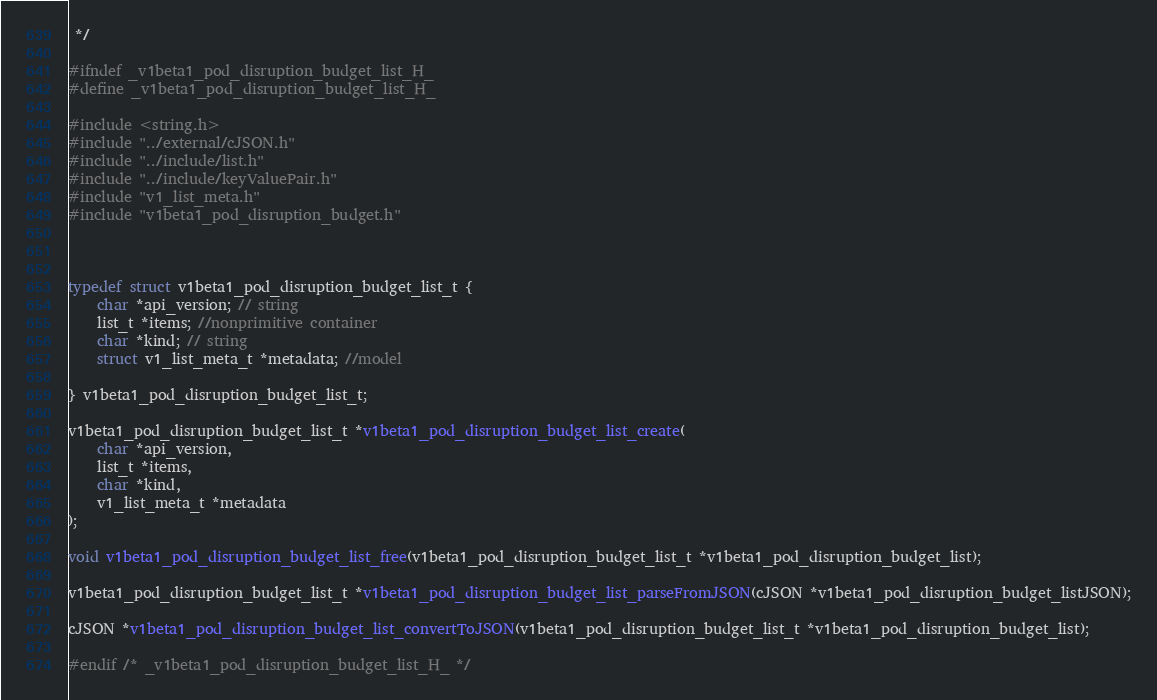<code> <loc_0><loc_0><loc_500><loc_500><_C_> */

#ifndef _v1beta1_pod_disruption_budget_list_H_
#define _v1beta1_pod_disruption_budget_list_H_

#include <string.h>
#include "../external/cJSON.h"
#include "../include/list.h"
#include "../include/keyValuePair.h"
#include "v1_list_meta.h"
#include "v1beta1_pod_disruption_budget.h"



typedef struct v1beta1_pod_disruption_budget_list_t {
    char *api_version; // string
    list_t *items; //nonprimitive container
    char *kind; // string
    struct v1_list_meta_t *metadata; //model

} v1beta1_pod_disruption_budget_list_t;

v1beta1_pod_disruption_budget_list_t *v1beta1_pod_disruption_budget_list_create(
    char *api_version,
    list_t *items,
    char *kind,
    v1_list_meta_t *metadata
);

void v1beta1_pod_disruption_budget_list_free(v1beta1_pod_disruption_budget_list_t *v1beta1_pod_disruption_budget_list);

v1beta1_pod_disruption_budget_list_t *v1beta1_pod_disruption_budget_list_parseFromJSON(cJSON *v1beta1_pod_disruption_budget_listJSON);

cJSON *v1beta1_pod_disruption_budget_list_convertToJSON(v1beta1_pod_disruption_budget_list_t *v1beta1_pod_disruption_budget_list);

#endif /* _v1beta1_pod_disruption_budget_list_H_ */

</code> 